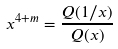<formula> <loc_0><loc_0><loc_500><loc_500>x ^ { 4 + m } = \frac { Q ( 1 / x ) } { Q ( x ) }</formula> 